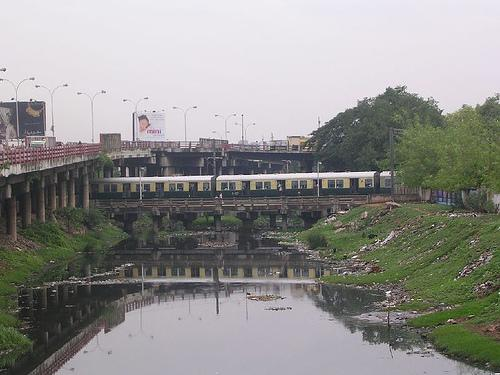What is the problem in this area?

Choices:
A) water shortage
B) traffic congestion
C) water pollution
D) landslide water pollution 